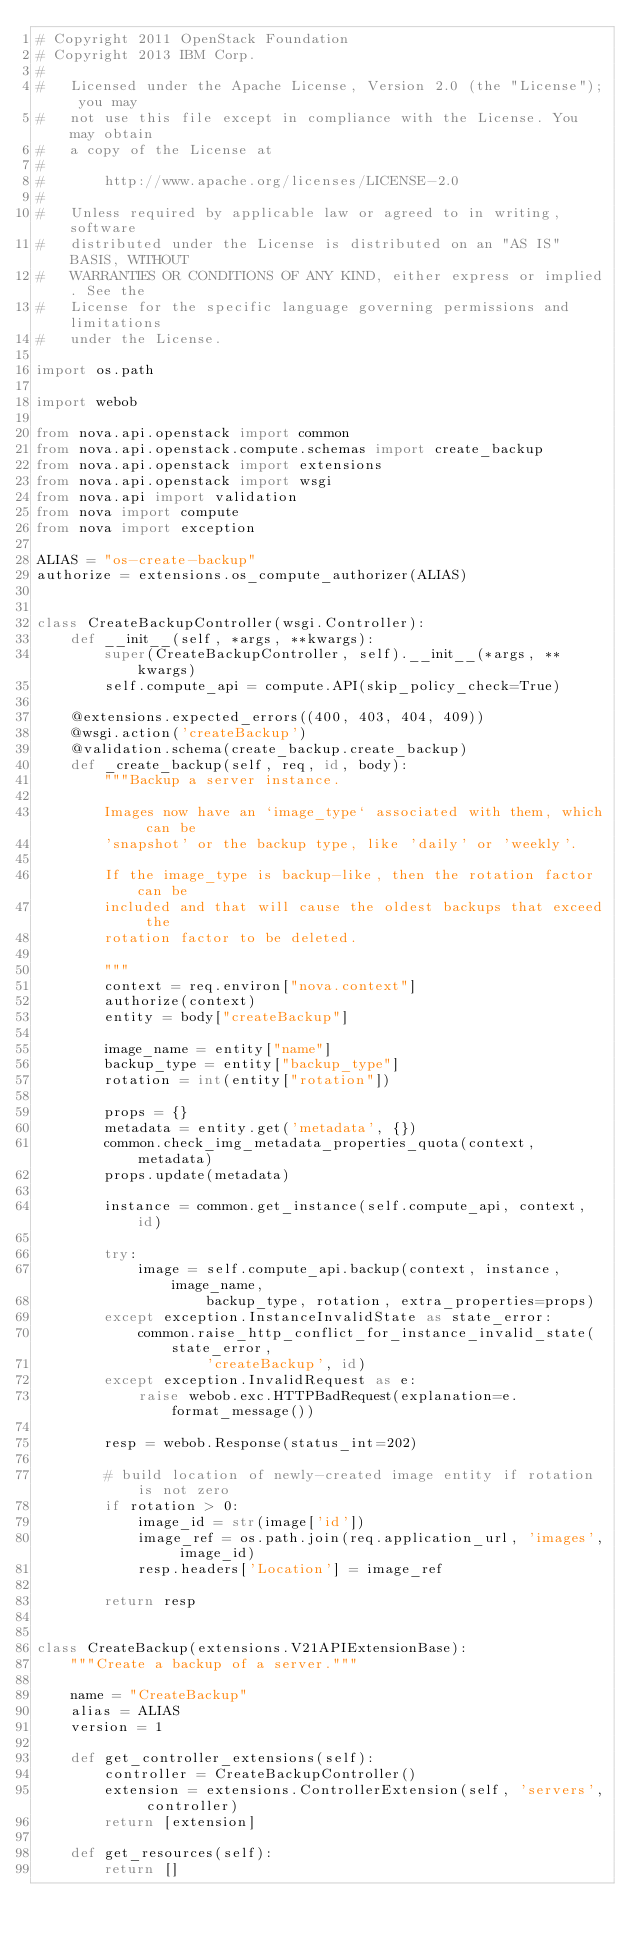Convert code to text. <code><loc_0><loc_0><loc_500><loc_500><_Python_># Copyright 2011 OpenStack Foundation
# Copyright 2013 IBM Corp.
#
#   Licensed under the Apache License, Version 2.0 (the "License"); you may
#   not use this file except in compliance with the License. You may obtain
#   a copy of the License at
#
#       http://www.apache.org/licenses/LICENSE-2.0
#
#   Unless required by applicable law or agreed to in writing, software
#   distributed under the License is distributed on an "AS IS" BASIS, WITHOUT
#   WARRANTIES OR CONDITIONS OF ANY KIND, either express or implied. See the
#   License for the specific language governing permissions and limitations
#   under the License.

import os.path

import webob

from nova.api.openstack import common
from nova.api.openstack.compute.schemas import create_backup
from nova.api.openstack import extensions
from nova.api.openstack import wsgi
from nova.api import validation
from nova import compute
from nova import exception

ALIAS = "os-create-backup"
authorize = extensions.os_compute_authorizer(ALIAS)


class CreateBackupController(wsgi.Controller):
    def __init__(self, *args, **kwargs):
        super(CreateBackupController, self).__init__(*args, **kwargs)
        self.compute_api = compute.API(skip_policy_check=True)

    @extensions.expected_errors((400, 403, 404, 409))
    @wsgi.action('createBackup')
    @validation.schema(create_backup.create_backup)
    def _create_backup(self, req, id, body):
        """Backup a server instance.

        Images now have an `image_type` associated with them, which can be
        'snapshot' or the backup type, like 'daily' or 'weekly'.

        If the image_type is backup-like, then the rotation factor can be
        included and that will cause the oldest backups that exceed the
        rotation factor to be deleted.

        """
        context = req.environ["nova.context"]
        authorize(context)
        entity = body["createBackup"]

        image_name = entity["name"]
        backup_type = entity["backup_type"]
        rotation = int(entity["rotation"])

        props = {}
        metadata = entity.get('metadata', {})
        common.check_img_metadata_properties_quota(context, metadata)
        props.update(metadata)

        instance = common.get_instance(self.compute_api, context, id)

        try:
            image = self.compute_api.backup(context, instance, image_name,
                    backup_type, rotation, extra_properties=props)
        except exception.InstanceInvalidState as state_error:
            common.raise_http_conflict_for_instance_invalid_state(state_error,
                    'createBackup', id)
        except exception.InvalidRequest as e:
            raise webob.exc.HTTPBadRequest(explanation=e.format_message())

        resp = webob.Response(status_int=202)

        # build location of newly-created image entity if rotation is not zero
        if rotation > 0:
            image_id = str(image['id'])
            image_ref = os.path.join(req.application_url, 'images', image_id)
            resp.headers['Location'] = image_ref

        return resp


class CreateBackup(extensions.V21APIExtensionBase):
    """Create a backup of a server."""

    name = "CreateBackup"
    alias = ALIAS
    version = 1

    def get_controller_extensions(self):
        controller = CreateBackupController()
        extension = extensions.ControllerExtension(self, 'servers', controller)
        return [extension]

    def get_resources(self):
        return []
</code> 